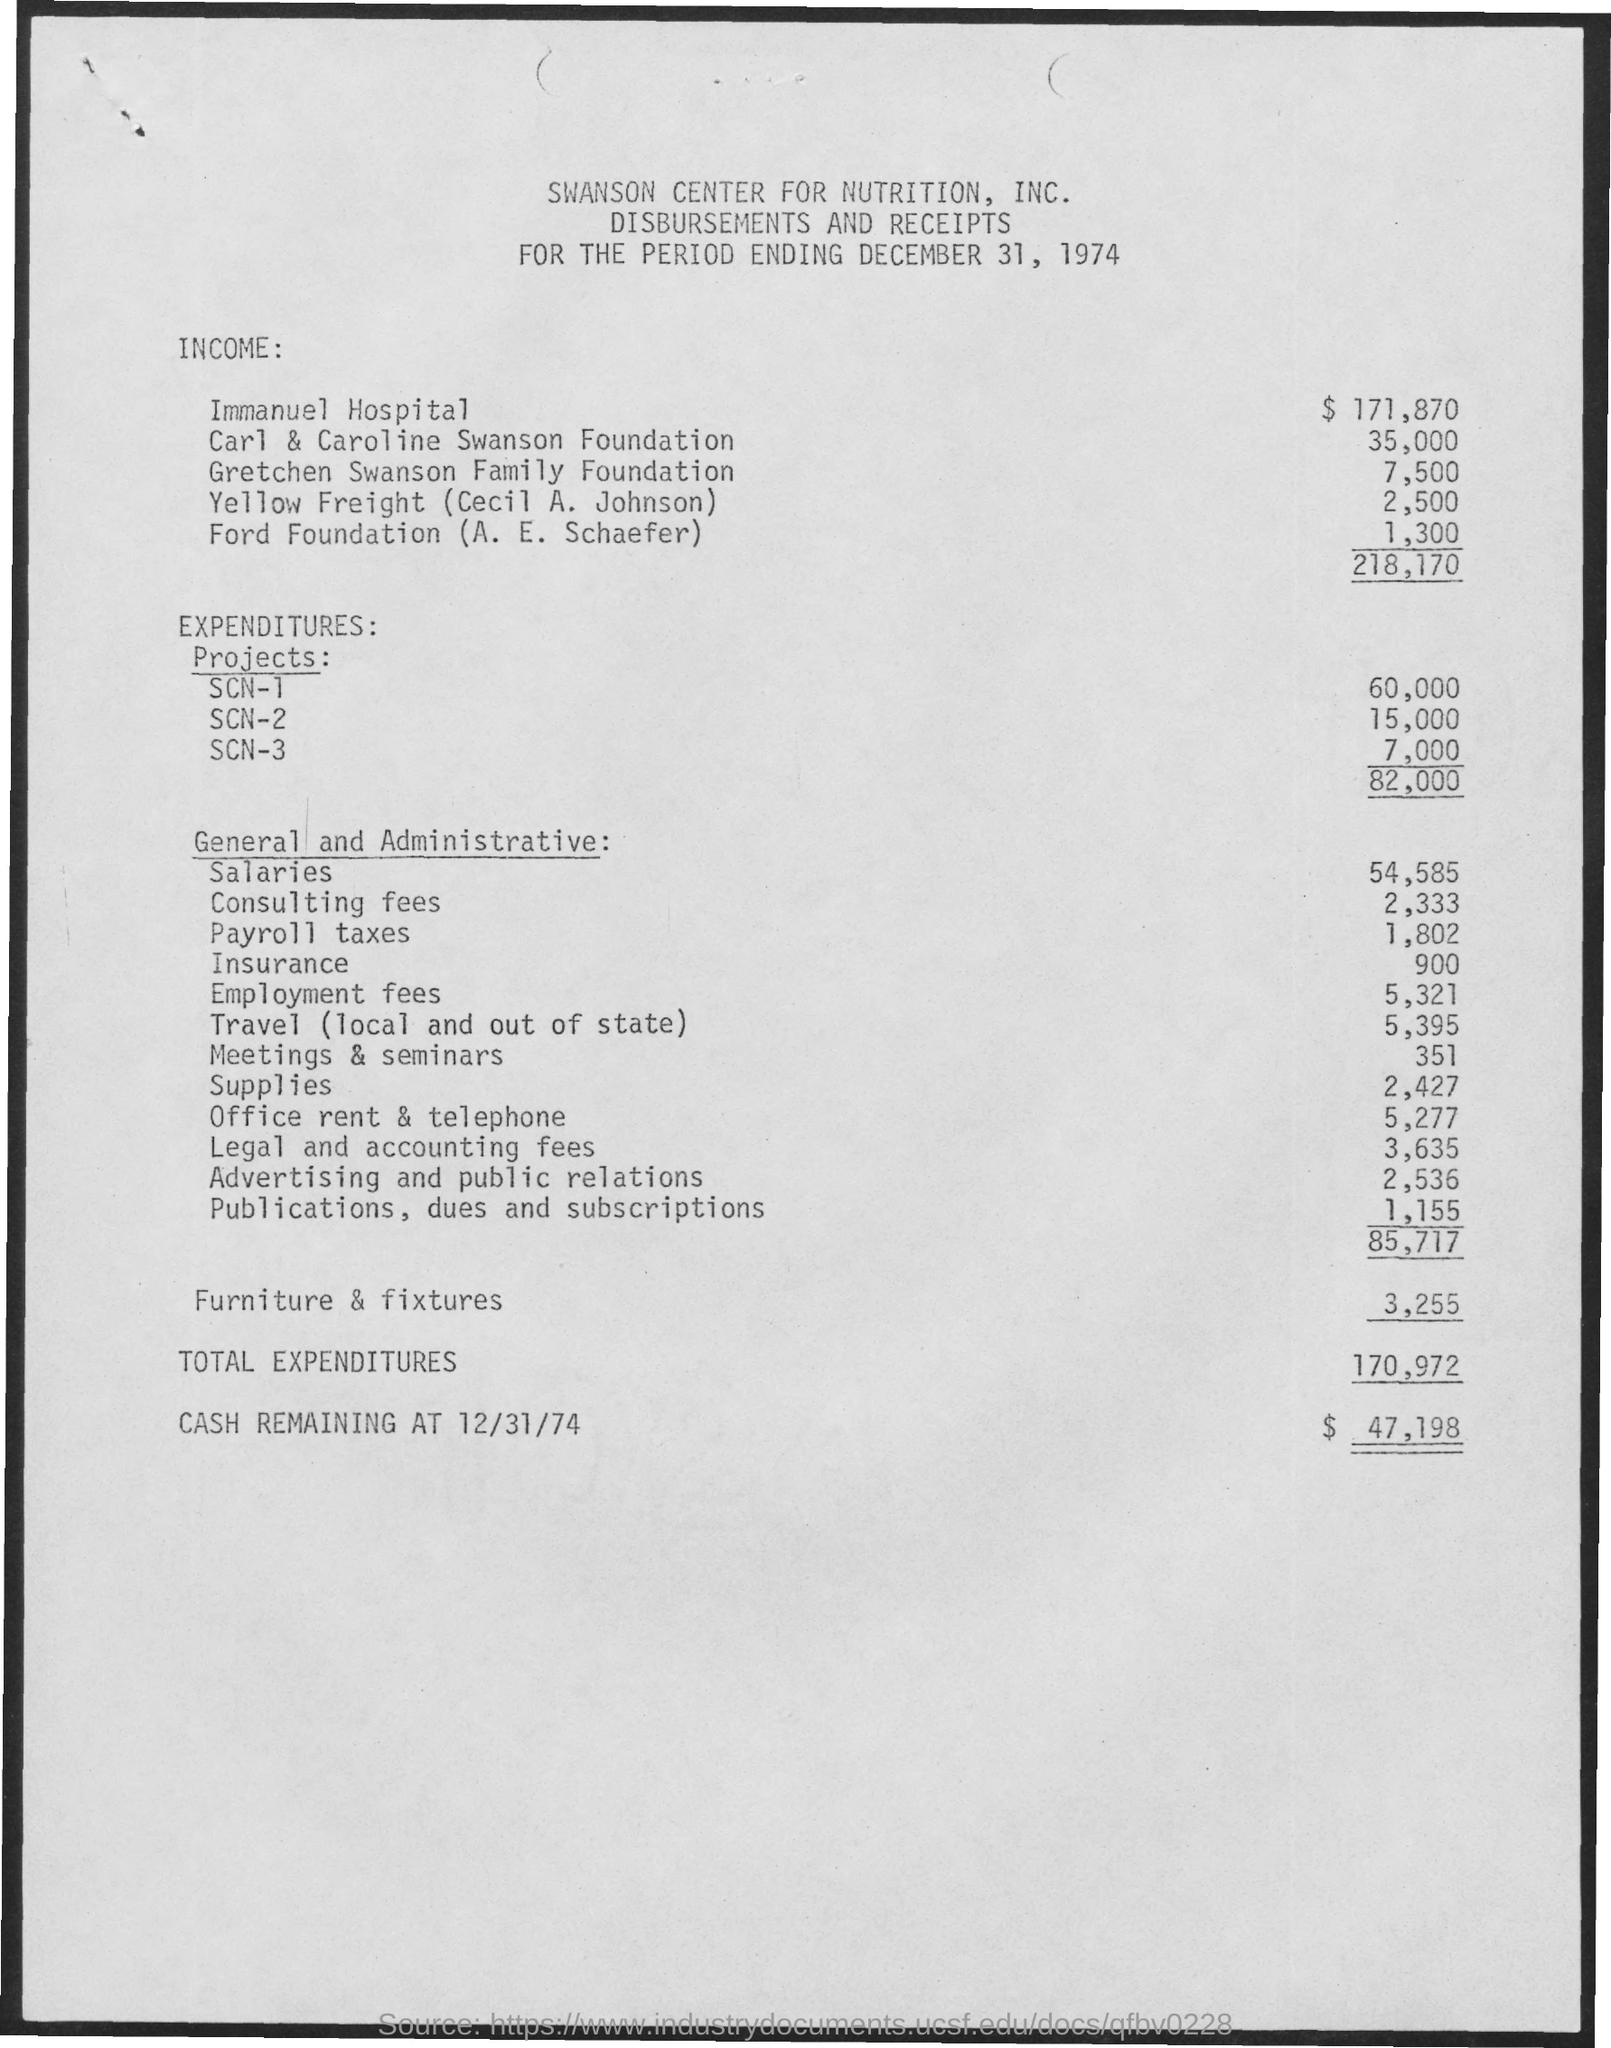Point out several critical features in this image. The expenditures for Project SCN-1 are 60,000. The expenditures for Project SCN-3 are 7,000.. The income for Yello Freight, specifically Cecil A. Johnson, is 2,500. The income for the Gretchen Swanson family Foundation is 7,500. General and administrative insurance is a type of insurance coverage that provides protection against the expenses associated with operating a business, such as rent, utilities, and salaries. 